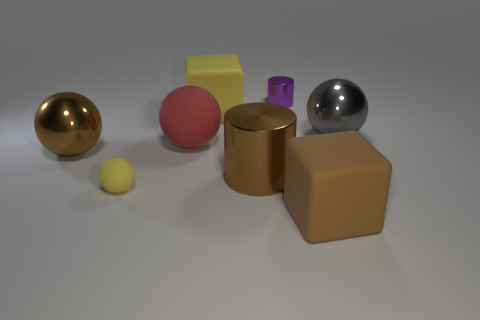There is a big rubber block that is on the left side of the brown rubber block; does it have the same color as the small rubber sphere? The big rubber block on the left side is yellow, which is not the same color as the small rubber sphere that appears to be pink. 